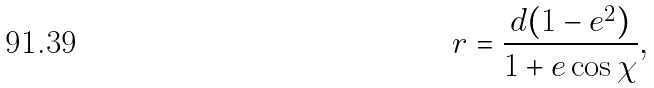Convert formula to latex. <formula><loc_0><loc_0><loc_500><loc_500>r = \frac { d ( 1 - e ^ { 2 } ) } { 1 + e \cos \chi } ,</formula> 